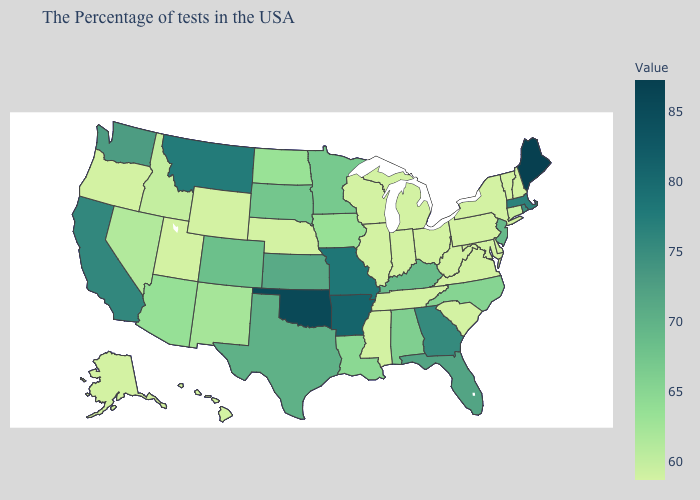Does California have the highest value in the West?
Be succinct. No. Which states have the highest value in the USA?
Keep it brief. Maine. Which states have the lowest value in the West?
Write a very short answer. Wyoming, Utah, Oregon, Alaska, Hawaii. Among the states that border Iowa , which have the lowest value?
Give a very brief answer. Wisconsin, Illinois, Nebraska. Does Rhode Island have a higher value than Pennsylvania?
Be succinct. Yes. Among the states that border Montana , which have the highest value?
Write a very short answer. South Dakota. Which states hav the highest value in the Northeast?
Be succinct. Maine. Does the map have missing data?
Give a very brief answer. No. Which states have the lowest value in the South?
Short answer required. Delaware, Maryland, Virginia, South Carolina, West Virginia, Tennessee, Mississippi. Among the states that border Illinois , does Wisconsin have the highest value?
Quick response, please. No. Does California have the lowest value in the West?
Keep it brief. No. Among the states that border Utah , which have the lowest value?
Answer briefly. Wyoming. 